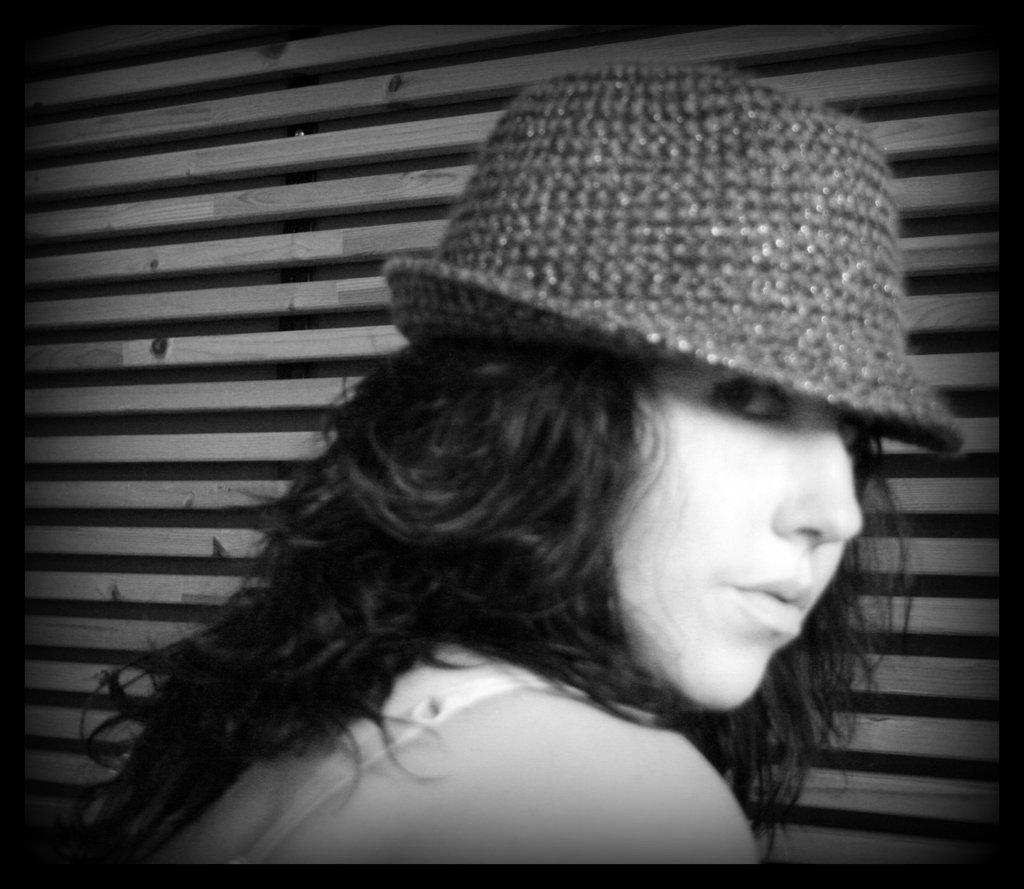What type of picture is in the image? The image contains a black and white picture. Who is depicted in the picture? The picture is of a woman wearing a hat. What can be seen in the background of the picture? There are wooden sticks in the background of the image. What type of stone can be seen floating in space in the image? There is no stone or space depicted in the image; it features a black and white picture of a woman wearing a hat with wooden sticks in the background. 